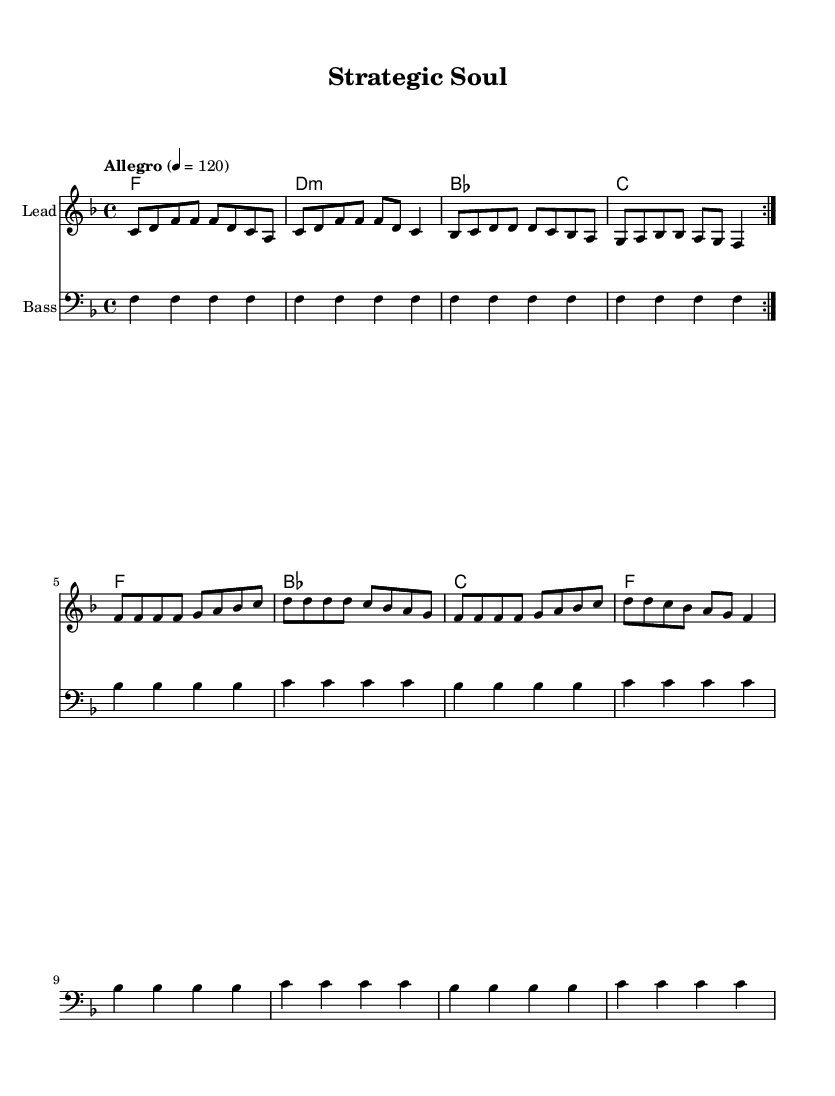What is the key signature of this music? The music is in F major, which has one flat (B flat) in its key signature. This can be identified by looking for the flat sign at the beginning of the staff.
Answer: F major What is the time signature of the piece? The time signature is indicated at the beginning of the score, showing that there are four beats in each measure and the quarter note gets one beat, represented as 4/4.
Answer: 4/4 What is the tempo marking of the piece? The tempo marking states "Allegro" with a metronome mark of "4 = 120," indicating a fast tempo. This is found above the staff where tempo indications are typically placed.
Answer: Allegro How many times is the melody repeated? The melody section is marked with "repeat volta 2," indicating that the melody should be played twice. This notation shows the repetition structure.
Answer: 2 What type of chord progression is used in the harmonies? The harmonies include a sequence of chords that follow a common progression found in soul music, particularly a I-IV-V progression with some variations. This can be determined by analyzing the chord names listed.
Answer: I-IV-V progression What is the main theme of the lyrics in this piece? The lyrics focus on strategic thinking and problem-solving in everyday life, emphasizing proactive planning and solutions. This can be understood by examining the message conveyed throughout both the verse and chorus.
Answer: Strategic thinking How does the lyrical content reflect characteristics of soul music? The lyrics embody common soul music themes of empowerment and resilience, emphasizing personal growth and strategy in life's challenges, which is a typical focus in soul music culture. This can be inferred by analyzing the emotional and motivational tone of the lyrics.
Answer: Empowerment and resilience 